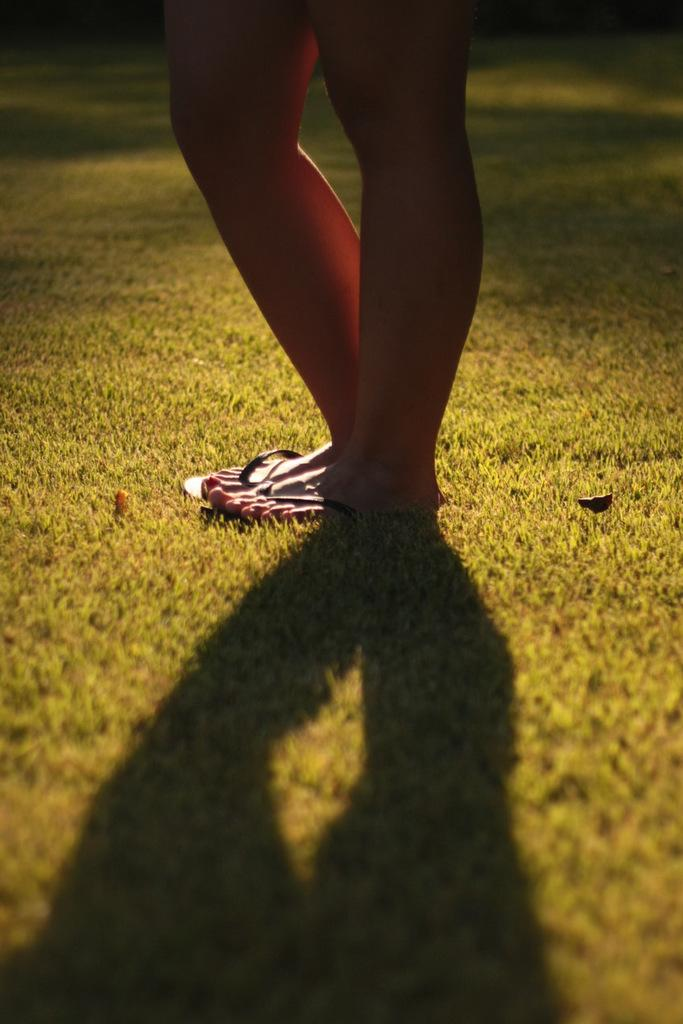Who or what is present in the image? There is a person in the image. What type of footwear is the person wearing? The person is wearing slippers. What type of surface is visible in the image? There is ground visible in the image. What can be seen in the image that indicates the presence of light? There is a shadow in the image, which suggests the presence of light. What type of plant is the person helping to grow in the image? There is no plant present in the image, and the person is not depicted helping to grow anything. 